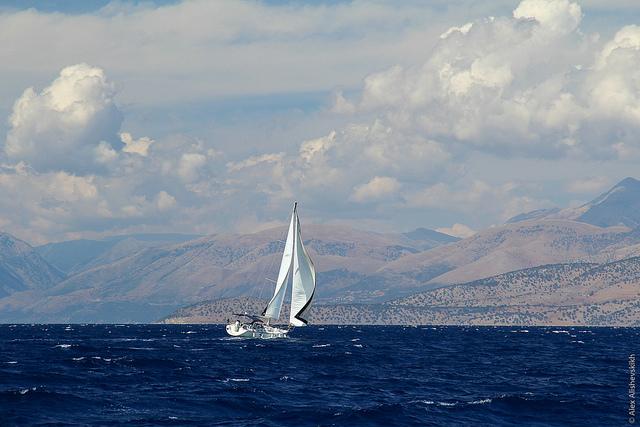Is there a house in the background?
Concise answer only. No. What city is the boat located in?
Give a very brief answer. San diego. Is the water calm?
Give a very brief answer. Yes. How many people are on the boat?
Concise answer only. 1. Is there clouds in the sky?
Write a very short answer. Yes. Is the sea calm?
Be succinct. Yes. What type of boat is in the water?
Concise answer only. Sailboat. 